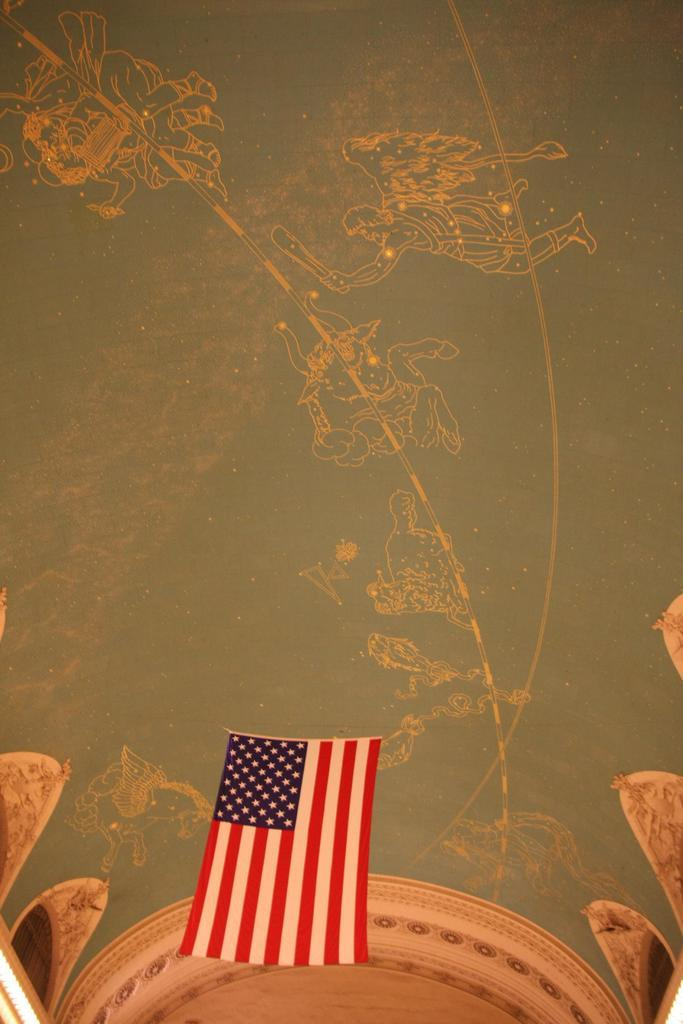What is the main subject of the image? The main subject of the image is the roof of a building. What can be seen in the middle of the roof? There is a flag in the middle of the roof. What is located at the top of the roof? There is artwork at the top of the roof. What type of birth can be seen taking place in the image? There is no birth taking place in the image; it shows the roof of a building with a flag and artwork. What kind of frame is used to support the artwork on the roof? There is no frame visible in the image; it only shows the artwork at the top of the roof. 